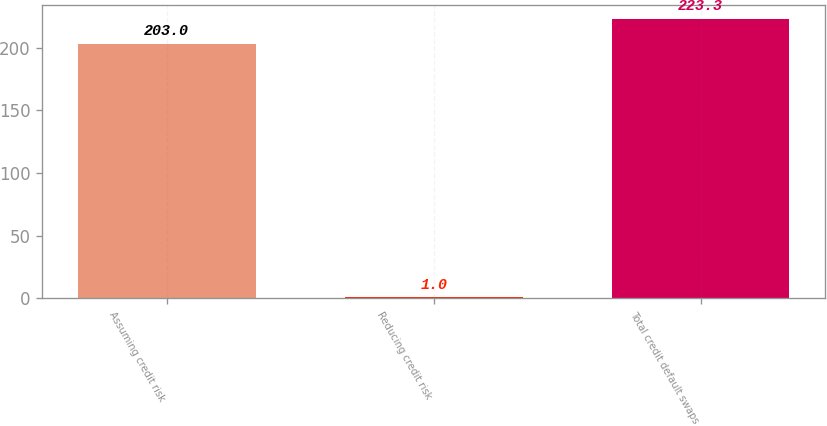Convert chart. <chart><loc_0><loc_0><loc_500><loc_500><bar_chart><fcel>Assuming credit risk<fcel>Reducing credit risk<fcel>Total credit default swaps<nl><fcel>203<fcel>1<fcel>223.3<nl></chart> 